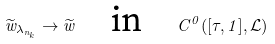Convert formula to latex. <formula><loc_0><loc_0><loc_500><loc_500>\widetilde { w } _ { \lambda _ { n _ { k } } } \to \widetilde { w } \quad \text {in} \quad C ^ { 0 } ( [ \tau , 1 ] , { \mathcal { L } } )</formula> 